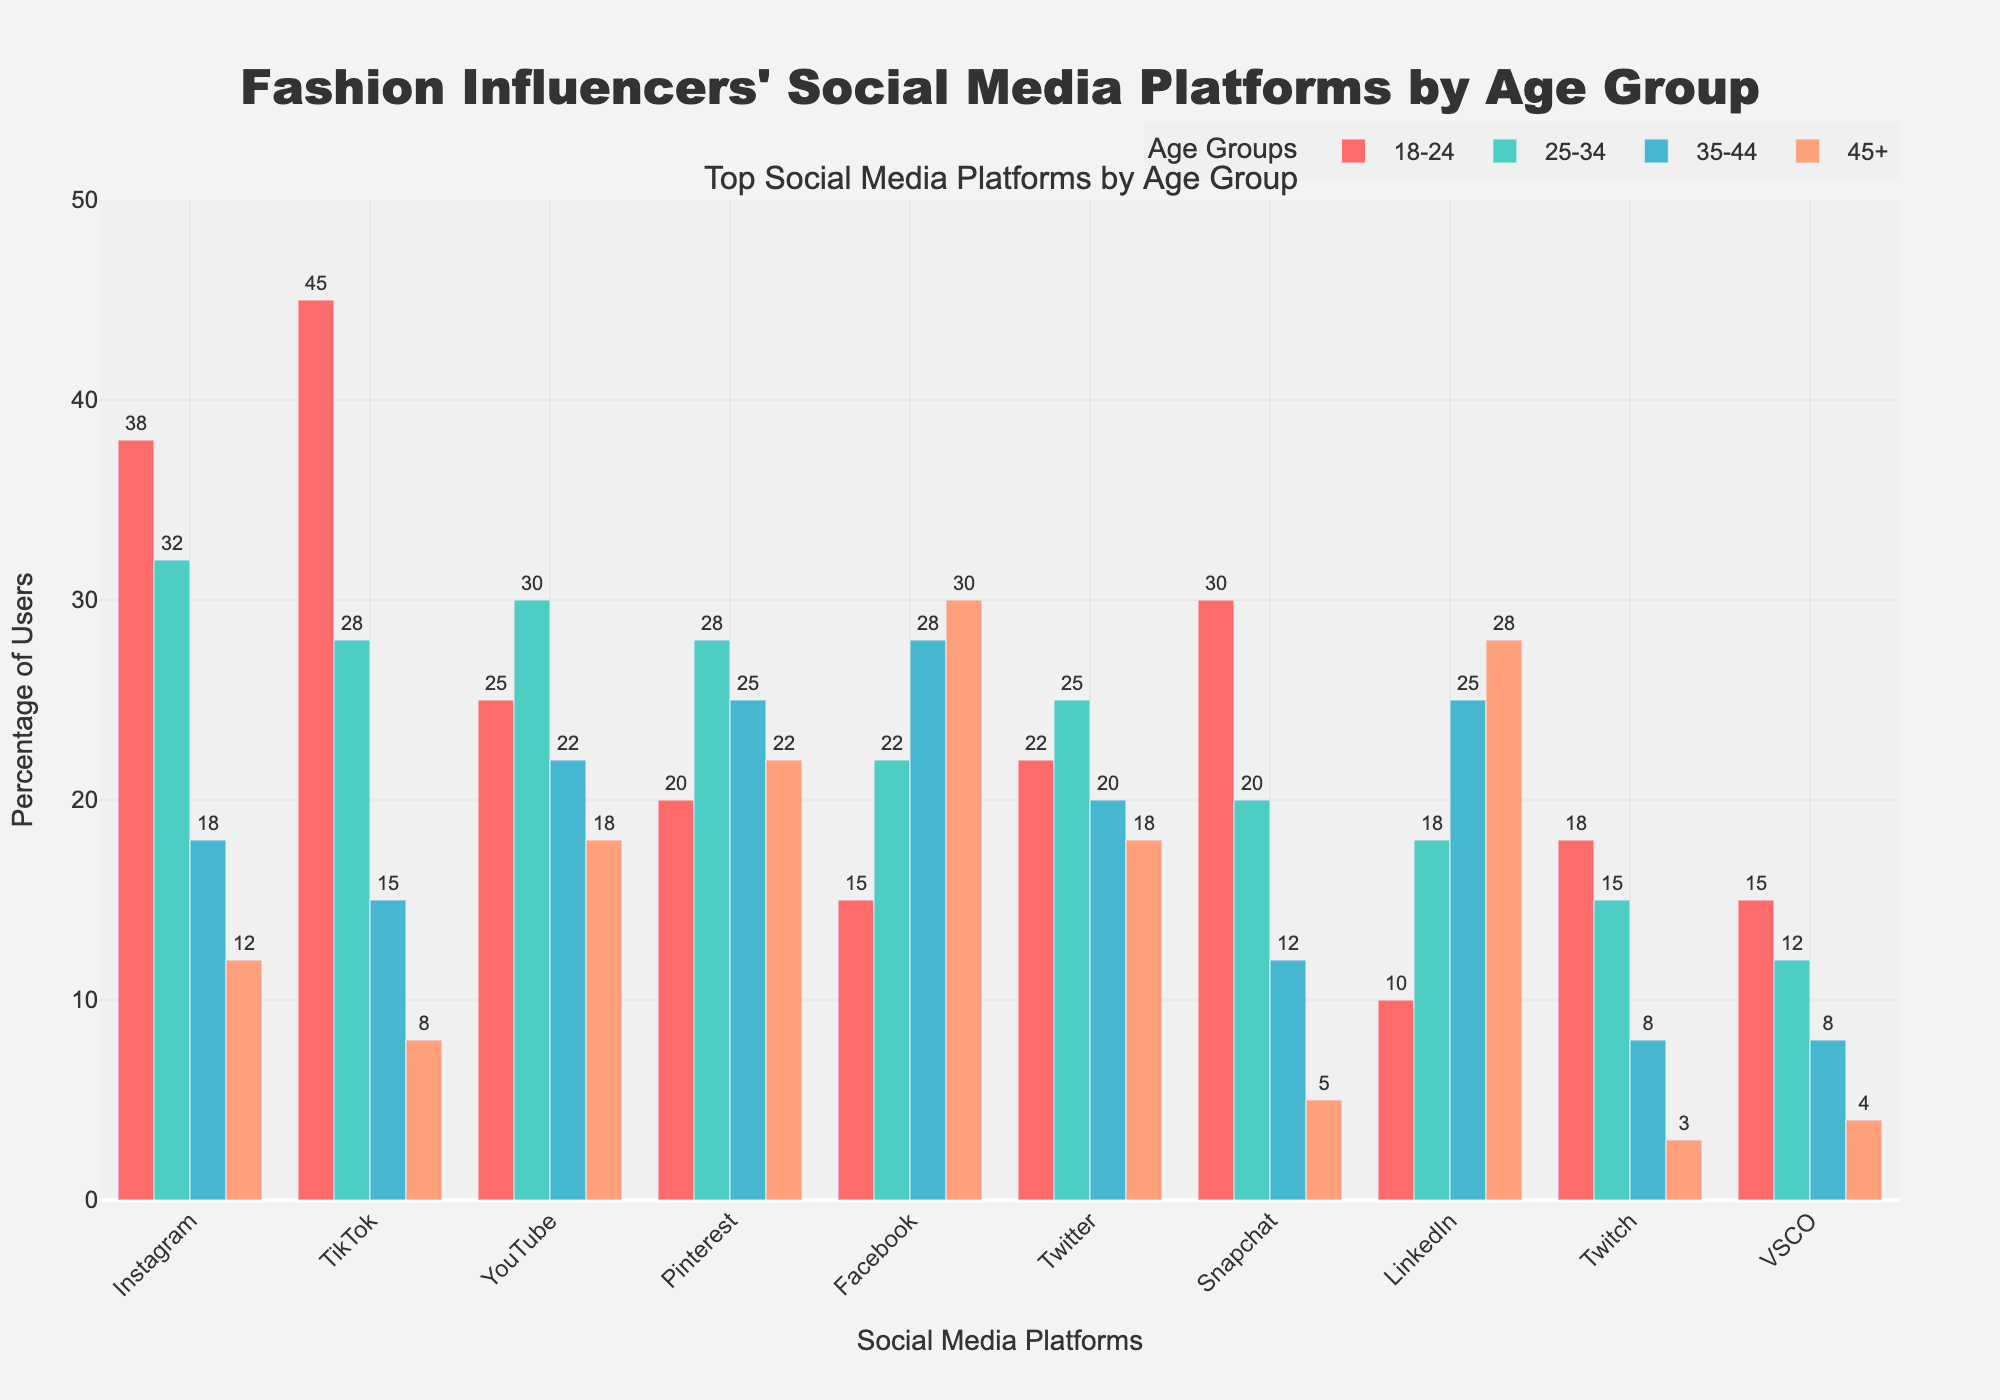what is the most popular social media platform for the 18-24 age group? The 18-24 age group bar with the highest value represents the most popular platform. The highest bar in this group is for TikTok.
Answer: TikTok Which age group has the highest Facebook usage? Identify which age group bar is the tallest for Facebook. The 45+ age group bar has the highest value for Facebook.
Answer: 45+ Which two platforms have the closest popularity among the 25-34 age group? Compare the heights of the bars for the two platforms with values closest to each other in the 25-34 age group. Instagram (32%) and YouTube (30%) have the closest values.
Answer: Instagram and YouTube Which social media platform shows a noticeable decline in usage as age increases? Look for platforms where the height of the bars decreases consistently from the 18-24 group to the 45+ group. TikTok shows a noticeable decline from 45% (18-24) to 8% (45+).
Answer: TikTok What is the average percentage usage of Pinterest across all age groups? Sum the percentage usage of Pinterest across all age groups and divide by the number of groups. (20+28+25+22)/4 = 95/4 = 23.75.
Answer: 23.75% Which social media platform has the least variance in usage percentage across all age groups? Check for the platform with bars of highly similar heights across all age groups. Pinterest has somewhat consistent usage percentages: 20%, 28%, 25%, and 22%.
Answer: Pinterest Which platform is the least popular among the 18-24 age group and the most popular among the 45+ age group? Find the platform with the smallest bar in the 18-24 age group and the tallest bar in the 45+ age group. LinkedIn has the lowest usage in the 18-24 group (10%) and one of the highest in the 45+ group (28%).
Answer: LinkedIn How many platforms have their highest usage percentage from the 18-24 age group? Count the platforms for which the highest bar belongs to the 18-24 age group. Platforms: TikTok, Instagram, Snapchat, VSCO, Twitch.
Answer: 5 Compare YouTube and Twitter, which age group shows the same user percentage for both platforms? Look for an age group where the bars for YouTube and Twitter are of the same height. For ages 35-44, both YouTube and Twitter show 20%.
Answer: 35-44 